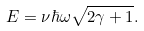Convert formula to latex. <formula><loc_0><loc_0><loc_500><loc_500>E = \nu \hbar { \omega } \sqrt { 2 \gamma + 1 } .</formula> 